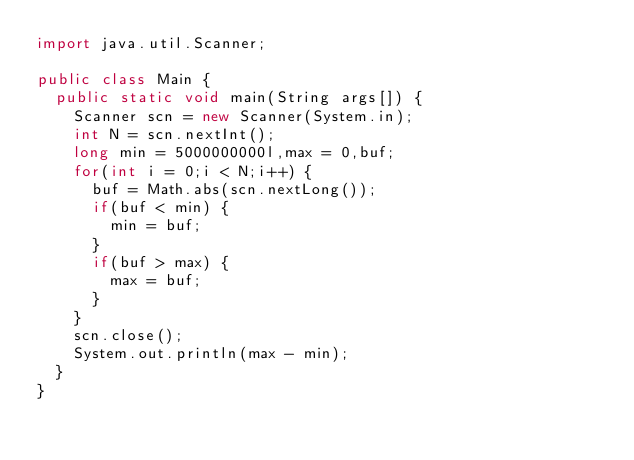Convert code to text. <code><loc_0><loc_0><loc_500><loc_500><_Java_>import java.util.Scanner;

public class Main {
	public static void main(String args[]) {
		Scanner scn = new Scanner(System.in);
		int N = scn.nextInt();
		long min = 5000000000l,max = 0,buf;
		for(int i = 0;i < N;i++) {
			buf = Math.abs(scn.nextLong());
			if(buf < min) {
				min = buf;
			}
			if(buf > max) {
				max = buf;
			}
		}
		scn.close();
		System.out.println(max - min);
	}
}
</code> 